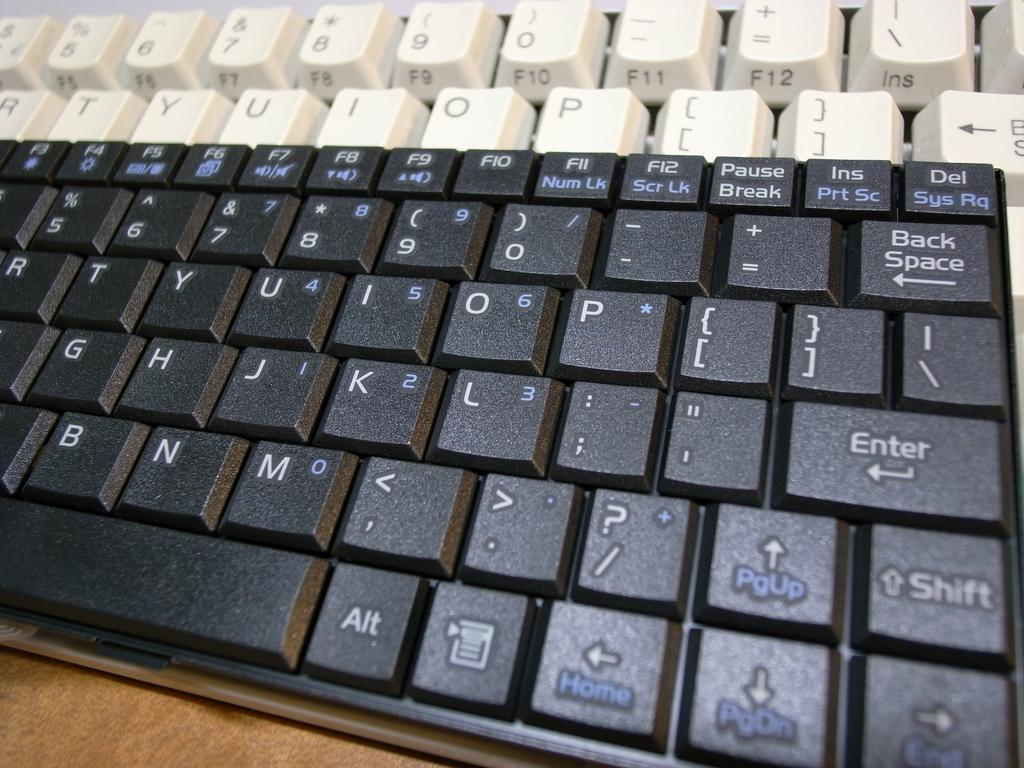Provide a one-sentence caption for the provided image. A black keyboard has the home key on the same key as the left arrow. 